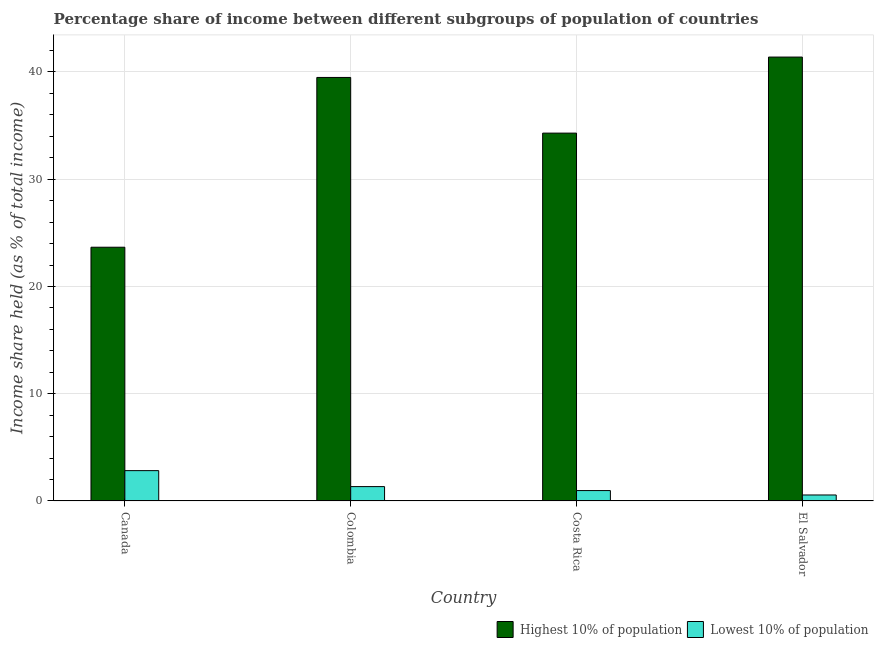How many groups of bars are there?
Give a very brief answer. 4. Are the number of bars per tick equal to the number of legend labels?
Offer a terse response. Yes. How many bars are there on the 1st tick from the left?
Your answer should be compact. 2. How many bars are there on the 1st tick from the right?
Make the answer very short. 2. In how many cases, is the number of bars for a given country not equal to the number of legend labels?
Offer a very short reply. 0. What is the income share held by highest 10% of the population in El Salvador?
Your response must be concise. 41.39. Across all countries, what is the maximum income share held by lowest 10% of the population?
Provide a short and direct response. 2.83. Across all countries, what is the minimum income share held by highest 10% of the population?
Keep it short and to the point. 23.66. What is the total income share held by highest 10% of the population in the graph?
Provide a succinct answer. 138.84. What is the difference between the income share held by highest 10% of the population in Canada and that in Costa Rica?
Make the answer very short. -10.64. What is the difference between the income share held by lowest 10% of the population in Costa Rica and the income share held by highest 10% of the population in El Salvador?
Ensure brevity in your answer.  -40.42. What is the average income share held by highest 10% of the population per country?
Offer a very short reply. 34.71. What is the difference between the income share held by highest 10% of the population and income share held by lowest 10% of the population in Canada?
Provide a succinct answer. 20.83. In how many countries, is the income share held by highest 10% of the population greater than 36 %?
Offer a very short reply. 2. What is the ratio of the income share held by highest 10% of the population in Canada to that in El Salvador?
Ensure brevity in your answer.  0.57. Is the income share held by lowest 10% of the population in Costa Rica less than that in El Salvador?
Your response must be concise. No. Is the difference between the income share held by lowest 10% of the population in Canada and Costa Rica greater than the difference between the income share held by highest 10% of the population in Canada and Costa Rica?
Offer a very short reply. Yes. What is the difference between the highest and the second highest income share held by lowest 10% of the population?
Your answer should be compact. 1.49. What is the difference between the highest and the lowest income share held by highest 10% of the population?
Your response must be concise. 17.73. Is the sum of the income share held by lowest 10% of the population in Canada and Costa Rica greater than the maximum income share held by highest 10% of the population across all countries?
Make the answer very short. No. What does the 2nd bar from the left in Colombia represents?
Your response must be concise. Lowest 10% of population. What does the 1st bar from the right in El Salvador represents?
Make the answer very short. Lowest 10% of population. How many bars are there?
Provide a succinct answer. 8. How many countries are there in the graph?
Offer a very short reply. 4. What is the difference between two consecutive major ticks on the Y-axis?
Make the answer very short. 10. Are the values on the major ticks of Y-axis written in scientific E-notation?
Keep it short and to the point. No. Does the graph contain any zero values?
Make the answer very short. No. How are the legend labels stacked?
Ensure brevity in your answer.  Horizontal. What is the title of the graph?
Provide a succinct answer. Percentage share of income between different subgroups of population of countries. What is the label or title of the X-axis?
Your answer should be very brief. Country. What is the label or title of the Y-axis?
Keep it short and to the point. Income share held (as % of total income). What is the Income share held (as % of total income) of Highest 10% of population in Canada?
Offer a very short reply. 23.66. What is the Income share held (as % of total income) of Lowest 10% of population in Canada?
Offer a terse response. 2.83. What is the Income share held (as % of total income) in Highest 10% of population in Colombia?
Your answer should be compact. 39.49. What is the Income share held (as % of total income) of Lowest 10% of population in Colombia?
Keep it short and to the point. 1.34. What is the Income share held (as % of total income) of Highest 10% of population in Costa Rica?
Provide a short and direct response. 34.3. What is the Income share held (as % of total income) in Highest 10% of population in El Salvador?
Make the answer very short. 41.39. What is the Income share held (as % of total income) of Lowest 10% of population in El Salvador?
Provide a short and direct response. 0.56. Across all countries, what is the maximum Income share held (as % of total income) of Highest 10% of population?
Provide a succinct answer. 41.39. Across all countries, what is the maximum Income share held (as % of total income) in Lowest 10% of population?
Your response must be concise. 2.83. Across all countries, what is the minimum Income share held (as % of total income) in Highest 10% of population?
Provide a succinct answer. 23.66. Across all countries, what is the minimum Income share held (as % of total income) in Lowest 10% of population?
Offer a very short reply. 0.56. What is the total Income share held (as % of total income) of Highest 10% of population in the graph?
Your answer should be very brief. 138.84. What is the difference between the Income share held (as % of total income) of Highest 10% of population in Canada and that in Colombia?
Your response must be concise. -15.83. What is the difference between the Income share held (as % of total income) in Lowest 10% of population in Canada and that in Colombia?
Your response must be concise. 1.49. What is the difference between the Income share held (as % of total income) of Highest 10% of population in Canada and that in Costa Rica?
Your answer should be compact. -10.64. What is the difference between the Income share held (as % of total income) in Lowest 10% of population in Canada and that in Costa Rica?
Your answer should be compact. 1.86. What is the difference between the Income share held (as % of total income) in Highest 10% of population in Canada and that in El Salvador?
Offer a terse response. -17.73. What is the difference between the Income share held (as % of total income) in Lowest 10% of population in Canada and that in El Salvador?
Your response must be concise. 2.27. What is the difference between the Income share held (as % of total income) of Highest 10% of population in Colombia and that in Costa Rica?
Give a very brief answer. 5.19. What is the difference between the Income share held (as % of total income) of Lowest 10% of population in Colombia and that in Costa Rica?
Your response must be concise. 0.37. What is the difference between the Income share held (as % of total income) of Lowest 10% of population in Colombia and that in El Salvador?
Your answer should be compact. 0.78. What is the difference between the Income share held (as % of total income) of Highest 10% of population in Costa Rica and that in El Salvador?
Your response must be concise. -7.09. What is the difference between the Income share held (as % of total income) of Lowest 10% of population in Costa Rica and that in El Salvador?
Provide a short and direct response. 0.41. What is the difference between the Income share held (as % of total income) of Highest 10% of population in Canada and the Income share held (as % of total income) of Lowest 10% of population in Colombia?
Your answer should be compact. 22.32. What is the difference between the Income share held (as % of total income) in Highest 10% of population in Canada and the Income share held (as % of total income) in Lowest 10% of population in Costa Rica?
Keep it short and to the point. 22.69. What is the difference between the Income share held (as % of total income) in Highest 10% of population in Canada and the Income share held (as % of total income) in Lowest 10% of population in El Salvador?
Your answer should be compact. 23.1. What is the difference between the Income share held (as % of total income) of Highest 10% of population in Colombia and the Income share held (as % of total income) of Lowest 10% of population in Costa Rica?
Ensure brevity in your answer.  38.52. What is the difference between the Income share held (as % of total income) of Highest 10% of population in Colombia and the Income share held (as % of total income) of Lowest 10% of population in El Salvador?
Provide a short and direct response. 38.93. What is the difference between the Income share held (as % of total income) in Highest 10% of population in Costa Rica and the Income share held (as % of total income) in Lowest 10% of population in El Salvador?
Your answer should be compact. 33.74. What is the average Income share held (as % of total income) in Highest 10% of population per country?
Provide a short and direct response. 34.71. What is the average Income share held (as % of total income) in Lowest 10% of population per country?
Offer a terse response. 1.43. What is the difference between the Income share held (as % of total income) of Highest 10% of population and Income share held (as % of total income) of Lowest 10% of population in Canada?
Give a very brief answer. 20.83. What is the difference between the Income share held (as % of total income) of Highest 10% of population and Income share held (as % of total income) of Lowest 10% of population in Colombia?
Your response must be concise. 38.15. What is the difference between the Income share held (as % of total income) in Highest 10% of population and Income share held (as % of total income) in Lowest 10% of population in Costa Rica?
Give a very brief answer. 33.33. What is the difference between the Income share held (as % of total income) of Highest 10% of population and Income share held (as % of total income) of Lowest 10% of population in El Salvador?
Ensure brevity in your answer.  40.83. What is the ratio of the Income share held (as % of total income) of Highest 10% of population in Canada to that in Colombia?
Ensure brevity in your answer.  0.6. What is the ratio of the Income share held (as % of total income) of Lowest 10% of population in Canada to that in Colombia?
Offer a terse response. 2.11. What is the ratio of the Income share held (as % of total income) in Highest 10% of population in Canada to that in Costa Rica?
Your answer should be very brief. 0.69. What is the ratio of the Income share held (as % of total income) in Lowest 10% of population in Canada to that in Costa Rica?
Offer a terse response. 2.92. What is the ratio of the Income share held (as % of total income) of Highest 10% of population in Canada to that in El Salvador?
Make the answer very short. 0.57. What is the ratio of the Income share held (as % of total income) in Lowest 10% of population in Canada to that in El Salvador?
Offer a terse response. 5.05. What is the ratio of the Income share held (as % of total income) in Highest 10% of population in Colombia to that in Costa Rica?
Ensure brevity in your answer.  1.15. What is the ratio of the Income share held (as % of total income) of Lowest 10% of population in Colombia to that in Costa Rica?
Give a very brief answer. 1.38. What is the ratio of the Income share held (as % of total income) of Highest 10% of population in Colombia to that in El Salvador?
Keep it short and to the point. 0.95. What is the ratio of the Income share held (as % of total income) in Lowest 10% of population in Colombia to that in El Salvador?
Provide a succinct answer. 2.39. What is the ratio of the Income share held (as % of total income) in Highest 10% of population in Costa Rica to that in El Salvador?
Keep it short and to the point. 0.83. What is the ratio of the Income share held (as % of total income) in Lowest 10% of population in Costa Rica to that in El Salvador?
Your answer should be very brief. 1.73. What is the difference between the highest and the second highest Income share held (as % of total income) in Lowest 10% of population?
Give a very brief answer. 1.49. What is the difference between the highest and the lowest Income share held (as % of total income) of Highest 10% of population?
Your answer should be compact. 17.73. What is the difference between the highest and the lowest Income share held (as % of total income) in Lowest 10% of population?
Your response must be concise. 2.27. 